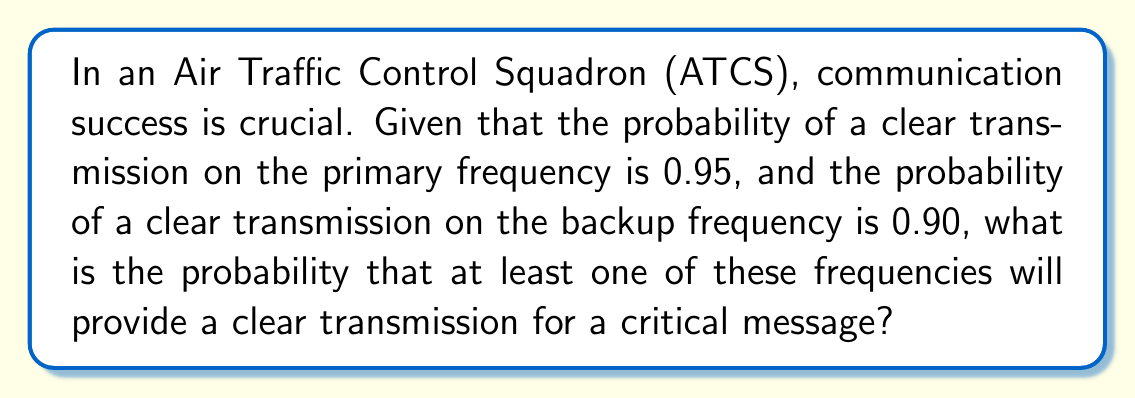Teach me how to tackle this problem. Let's approach this step-by-step:

1) Let A be the event of a clear transmission on the primary frequency (P(A) = 0.95)
   Let B be the event of a clear transmission on the backup frequency (P(B) = 0.90)

2) We want to find the probability of at least one clear transmission, which is the same as the probability of not having both transmissions fail.

3) The probability of both transmissions failing is:
   $P(\text{both fail}) = P(\text{A fails AND B fails}) = P(\text{not A}) \times P(\text{not B})$

4) $P(\text{not A}) = 1 - P(A) = 1 - 0.95 = 0.05$
   $P(\text{not B}) = 1 - P(B) = 1 - 0.90 = 0.10$

5) $P(\text{both fail}) = 0.05 \times 0.10 = 0.005$

6) Therefore, the probability of at least one clear transmission is:
   $P(\text{at least one clear}) = 1 - P(\text{both fail}) = 1 - 0.005 = 0.995$

This can also be calculated using the addition rule of probability:
$P(A \text{ or } B) = P(A) + P(B) - P(A \text{ and } B)$
$= 0.95 + 0.90 - (0.95 \times 0.90)$
$= 1.85 - 0.855 = 0.995$
Answer: 0.995 or 99.5% 